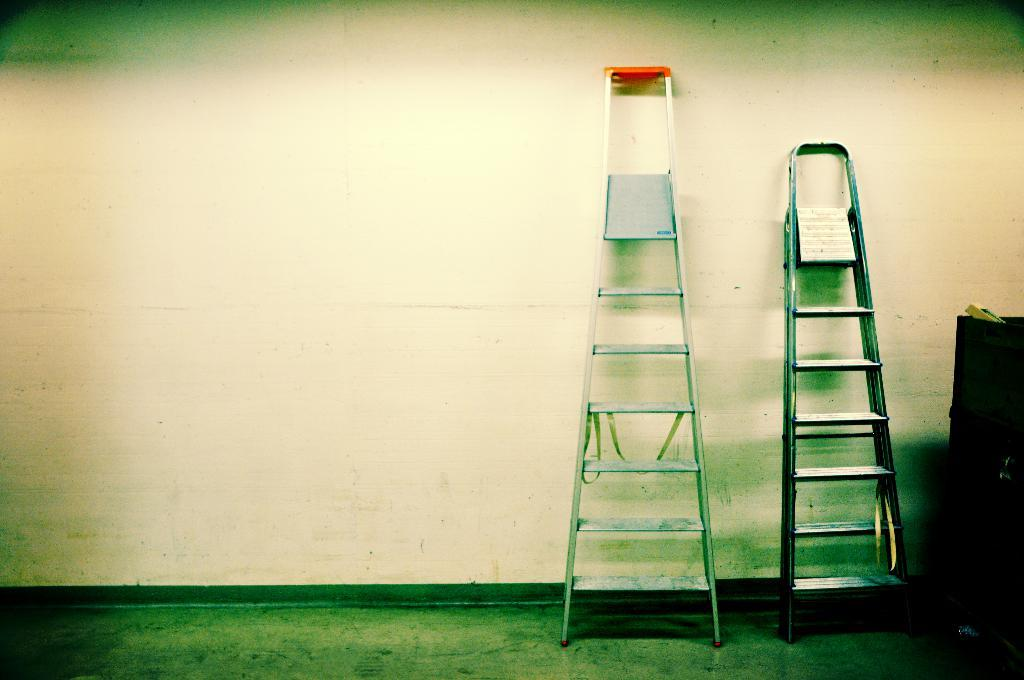What objects are on the floor in the image? There are ladders on the floor in the image. Can you describe the object visible in the image? Unfortunately, the provided facts do not give enough information to describe the object in detail. What can be seen in the background of the image? There is a wall in the background of the image. What type of fruit is being used to climb the ladders in the image? There are no fruits present in the image, and the ladders are not being climbed by any objects or individuals. 